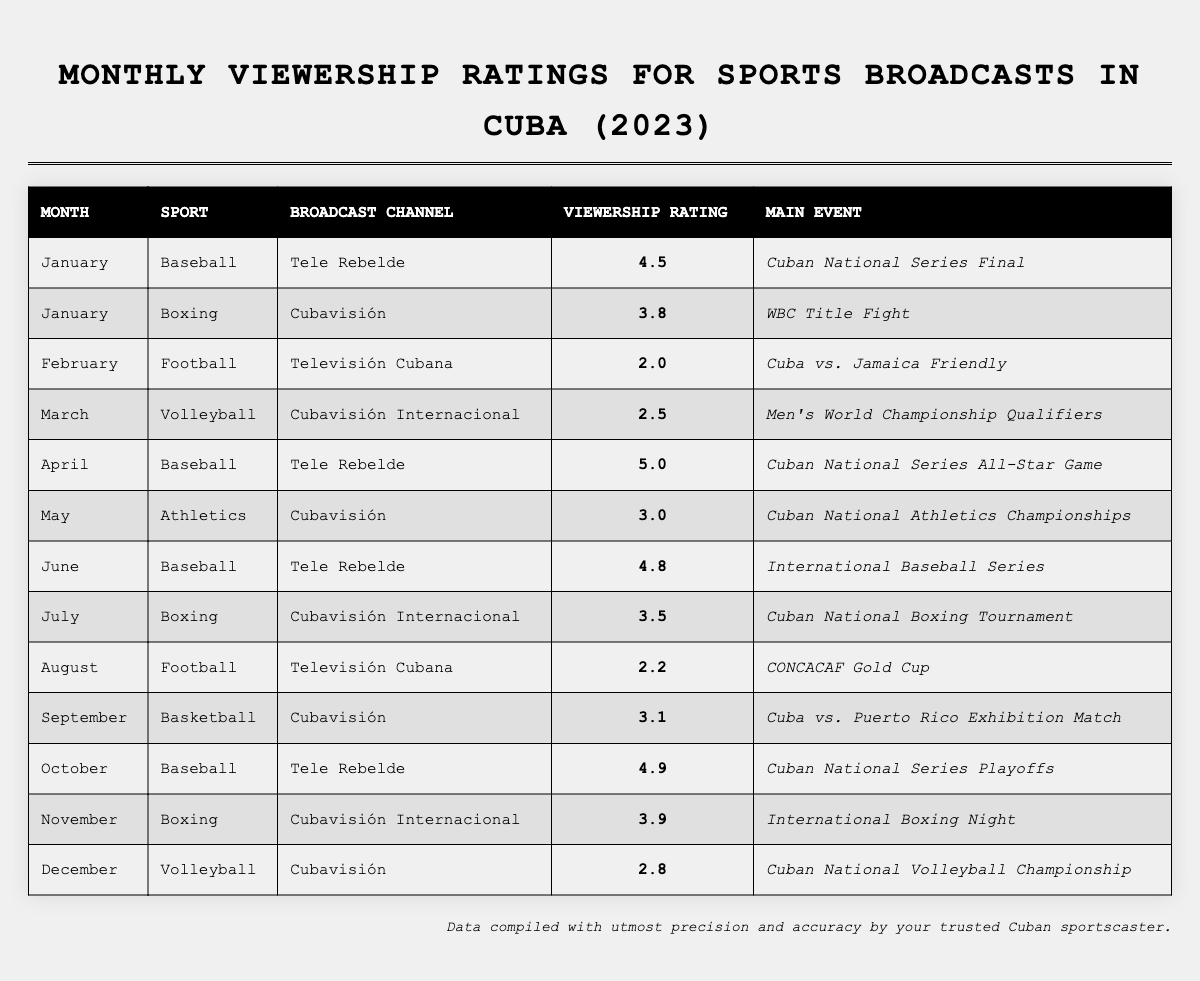What sport had the highest viewership rating in April? In April, the sport with the highest viewership rating is Baseball, with a rating of 5.0.
Answer: Baseball Which month had the lowest viewership rating for a sport? The lowest viewership rating in the table is 2.0, which occurred in February for Football.
Answer: February How many sports had a viewership rating of 4 or higher during the year? There are four instances of sports with viewership ratings of 4 or higher: Baseball in January (4.5), Baseball in April (5.0), Baseball in June (4.8), and Baseball in October (4.9). Therefore, there are four such occurrences.
Answer: 4 What was the average viewership rating for Boxing events? The viewership ratings for Boxing are 3.8 in January, 3.5 in July, and 3.9 in November. Summing these ratings gives (3.8 + 3.5 + 3.9) = 11.2, and dividing by the number of events (3) gives an average of 11.2 / 3 = 3.73.
Answer: 3.73 Was there a month in which Athletics had a higher rating than Football? Yes, in May, Athletics had a viewership rating of 3.0, which is higher than the viewership rating of 2.0 for Football in February.
Answer: Yes What is the total viewership rating for all Baseball broadcasts in 2023? The viewership ratings for Baseball are 4.5 in January, 5.0 in April, 4.8 in June, and 4.9 in October. Adding these gives (4.5 + 5.0 + 4.8 + 4.9) = 19.2.
Answer: 19.2 Which sport had a viewership rating above 3.0 and was broadcast on Cubavisión? The sport with a viewership rating above 3.0 on Cubavisión is Boxing in January (3.8) and Basketball in September (3.1). Both events qualify.
Answer: Boxing and Basketball How many different sports are listed in the table? The sports listed are Baseball, Boxing, Football, Volleyball, Athletics, and Basketball, totaling six different sports.
Answer: 6 What main event was the focus of the highest-rated broadcast in April? The highest-rated broadcast in April was the Cuban National Series All-Star Game, which had a rating of 5.0.
Answer: Cuban National Series All-Star Game In which month did Volleyball receive the highest viewership rating? Volleyball's highest viewership rating was 2.8 in December, which is the only entry for Volleyball in that month.
Answer: December 